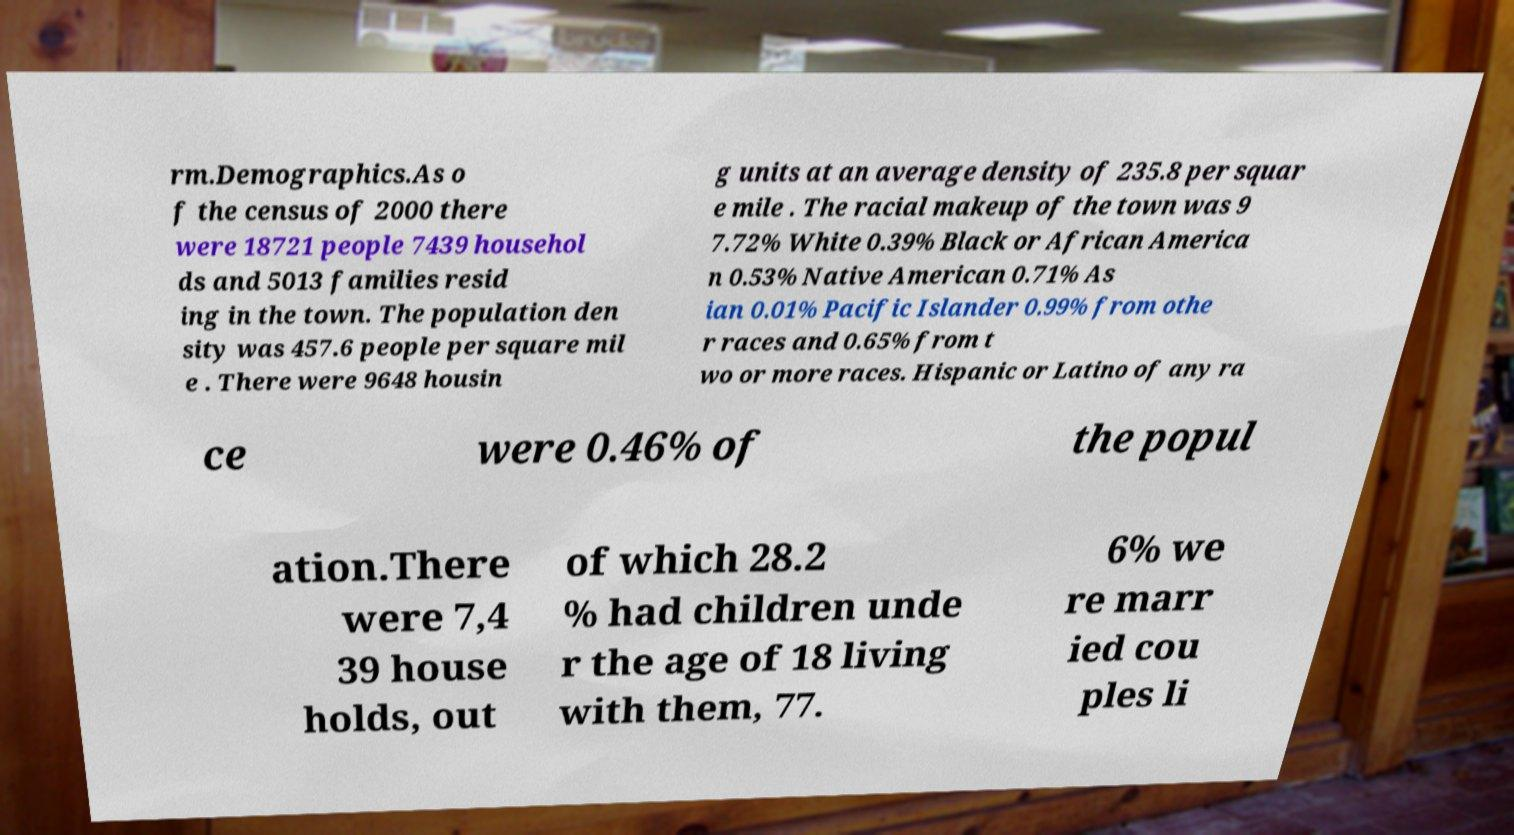There's text embedded in this image that I need extracted. Can you transcribe it verbatim? rm.Demographics.As o f the census of 2000 there were 18721 people 7439 househol ds and 5013 families resid ing in the town. The population den sity was 457.6 people per square mil e . There were 9648 housin g units at an average density of 235.8 per squar e mile . The racial makeup of the town was 9 7.72% White 0.39% Black or African America n 0.53% Native American 0.71% As ian 0.01% Pacific Islander 0.99% from othe r races and 0.65% from t wo or more races. Hispanic or Latino of any ra ce were 0.46% of the popul ation.There were 7,4 39 house holds, out of which 28.2 % had children unde r the age of 18 living with them, 77. 6% we re marr ied cou ples li 